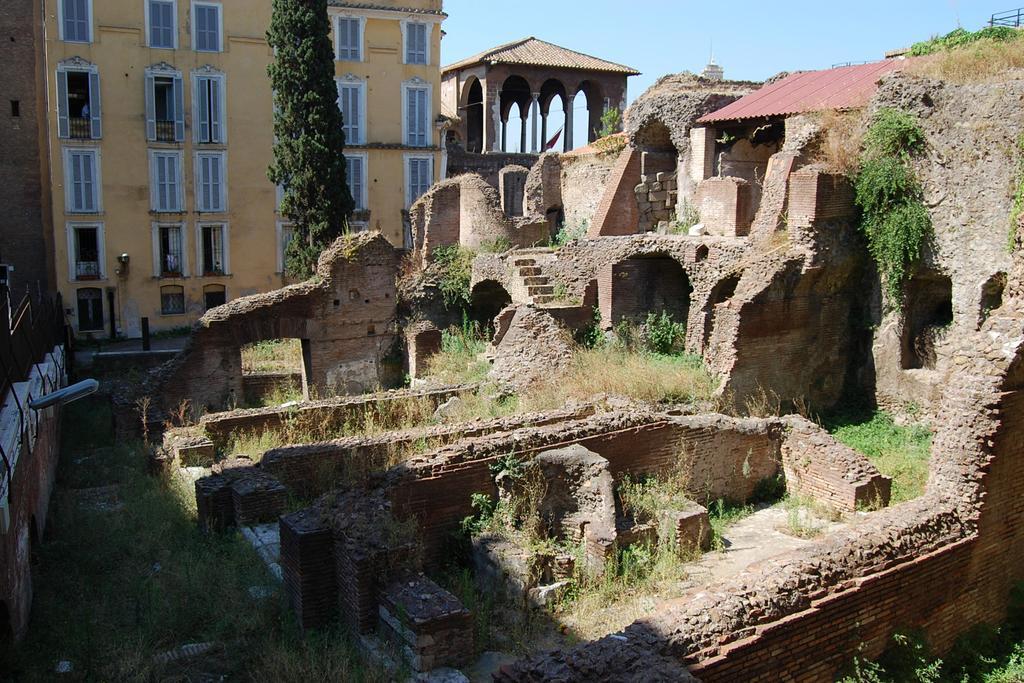Could you give a brief overview of what you see in this image? In this picture I can see the monuments and buildings. In front of the building I can see the trees. At the bottom I can see the grass. At the top there is a sky. 